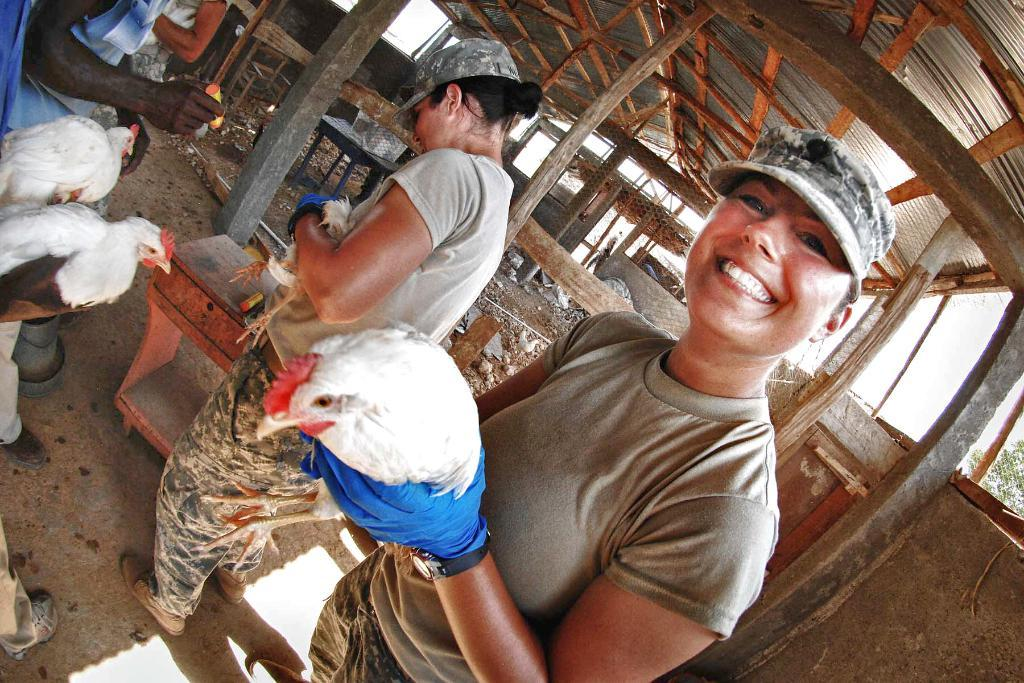What is happening in the image? There are people standing in the image, holding white and red color hens. What can be seen in the background of the image? There are tables visible in the background, as well as a wooden house and additional hens. What type of cup is being used by the people in the image? There is no cup visible in the image; the people are holding hens. 